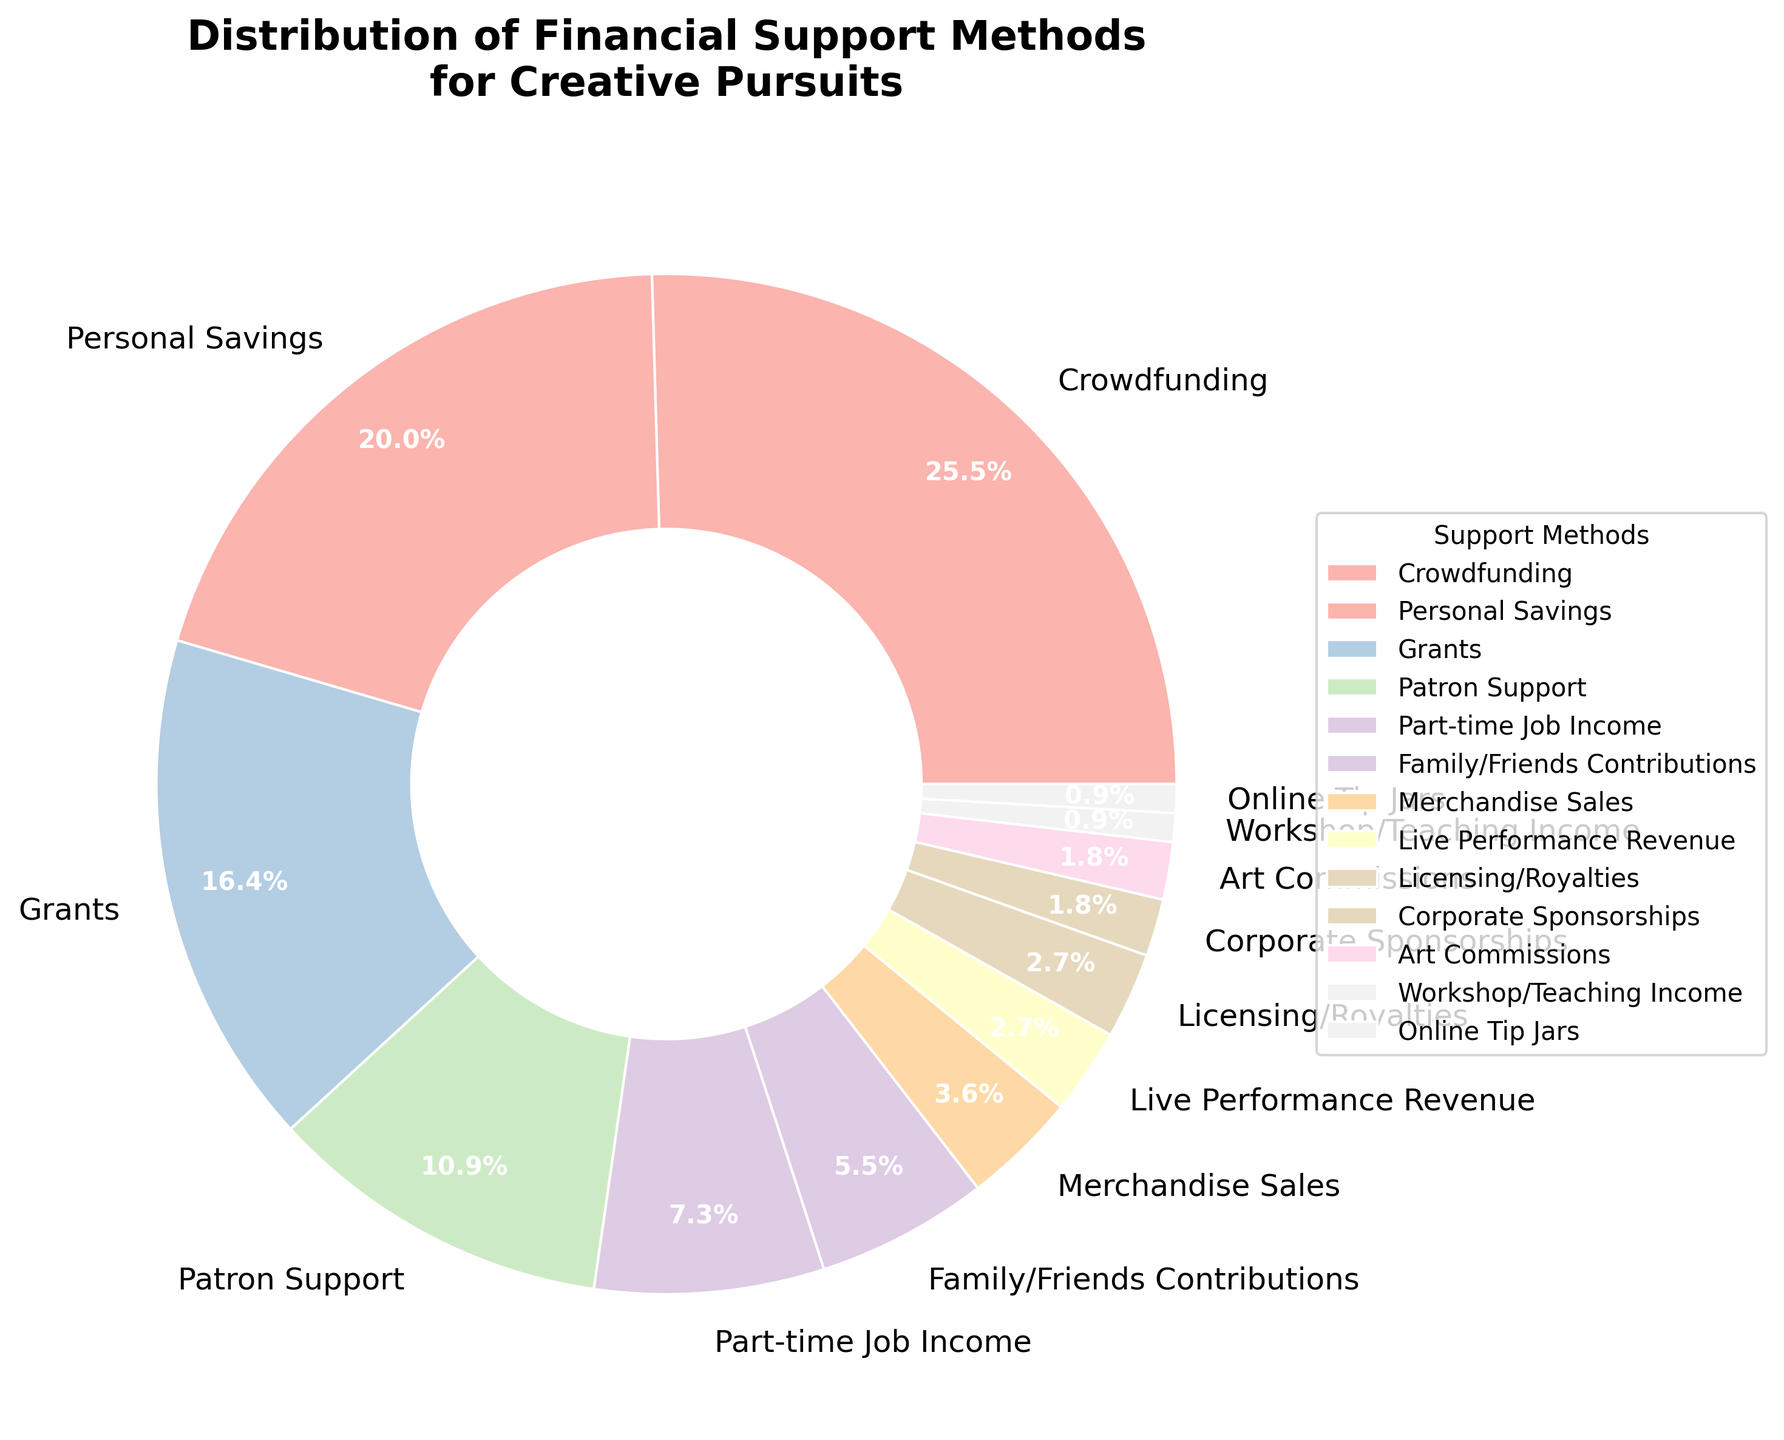Which method of financial support has the highest percentage? By looking at the pie chart, the method with the largest wedge represents the highest percentage. Crowdfunding occupies the largest segment.
Answer: Crowdfunding Which methods combined make up a quarter of the total financial support? Adding up the percentages of different methods to reach around 25%, we find that Family/Friends Contributions (6%) and Part-time Job Income (8%) total 14%, and adding Merchandise Sales (4%) and Live Performance Revenue (3%) sums up to 21%. Adding Licensing/Royalties (3%) reaches exactly 25%.
Answer: Family/Friends Contributions, Part-time Job Income, Merchandise Sales, Live Performance Revenue, Licensing/Royalties What is the difference in percentage between Crowdfunding and Grants? Referring to the pie chart, Crowdfunding is at 28% and Grants is at 18%. Subtracting these values, 28 - 18 = 10.
Answer: 10% Are there more methods with less than 5% or with 5% and above? By counting the methods, we note that Merchandise Sales (4%), Live Performance Revenue (3%), Licensing/Royalties (3%), Corporate Sponsorships (2%), Art Commissions (2%), Workshop/Teaching Income (1%), and Online Tip Jars (1%) each have less than 5%. That’s 7 methods. Methods with 5% and above are Crowdfunding (28%), Personal Savings (22%), Grants (18%), Patron Support (12%), Part-time Job Income (8%), and Family/Friends Contributions (6%)—6 methods in total.
Answer: Less than 5% Which method is represented by the lightest color in the chart? Generally, lighter colors are used for smaller segments. By visually identifying the smallest and notably light-colored segment, the lightest color in the pie chart represents Online Tip Jars, which makes up only 1% of the total.
Answer: Online Tip Jars What is the combined percentage of methods with individual percentages below 3%? Summing the percentages of Corporate Sponsorships (2%), Art Commissions (2%), Workshop/Teaching Income (1%), and Online Tip Jars (1%), we get 2 + 2 + 1 + 1 = 6.
Answer: 6% Is Personal Savings a larger source of financial support than Patron Support? Referring to the pie chart, Personal Savings holds 22% while Patron Support holds 12%. Since 22% is greater than 12%, Personal Savings is larger.
Answer: Yes Which method has the smallest percentage, and what is that percentage? By examining the segments, the smallest segment represents 1%. Methods sharing this value are Workshop/Teaching Income and Online Tip Jars.
Answer: Workshop/Teaching Income, Online Tip Jars (1%) 